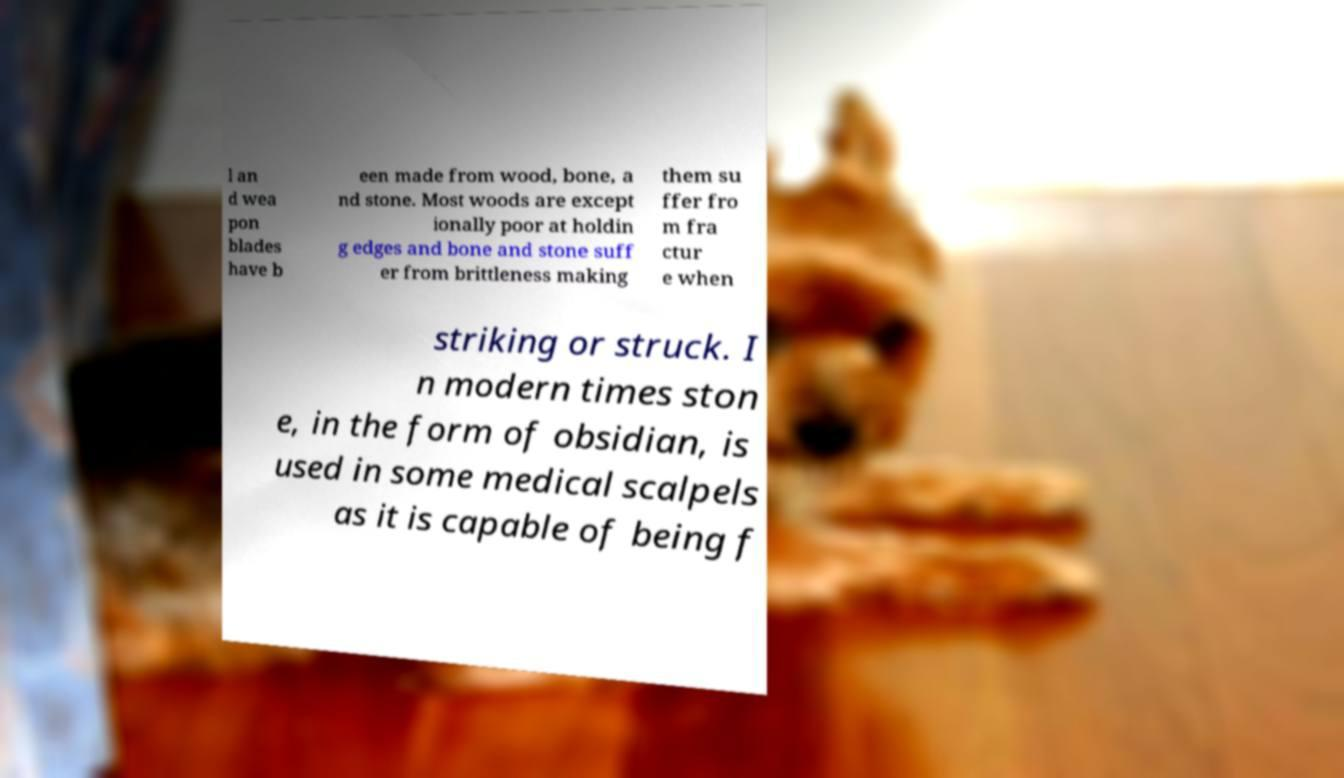For documentation purposes, I need the text within this image transcribed. Could you provide that? l an d wea pon blades have b een made from wood, bone, a nd stone. Most woods are except ionally poor at holdin g edges and bone and stone suff er from brittleness making them su ffer fro m fra ctur e when striking or struck. I n modern times ston e, in the form of obsidian, is used in some medical scalpels as it is capable of being f 